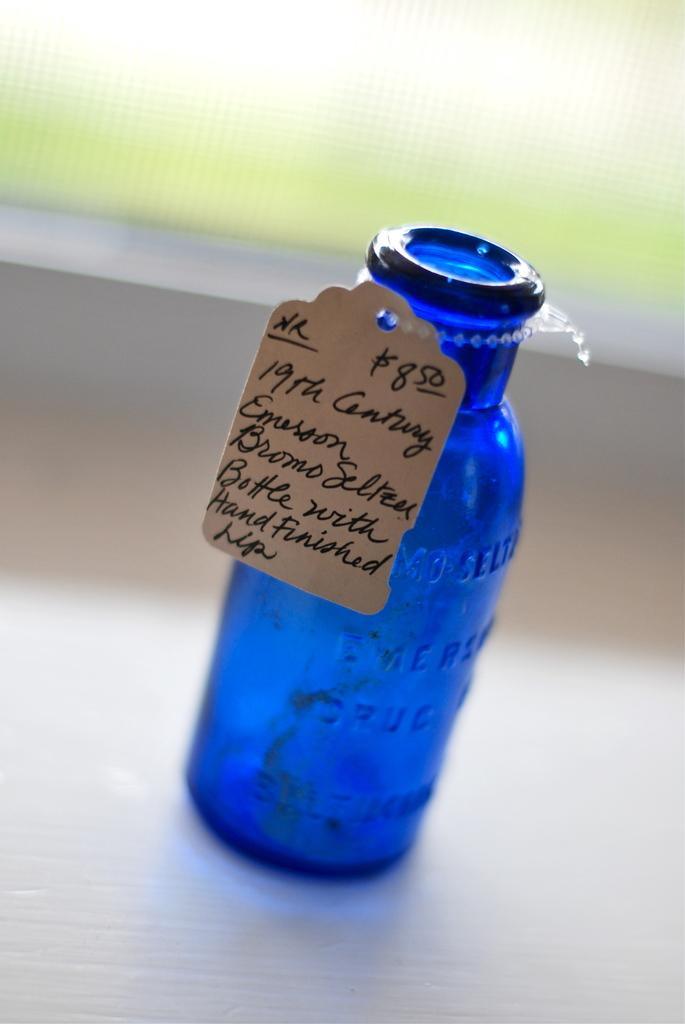Provide a one-sentence caption for the provided image. A blue bottle that is from the nineteenth century. 